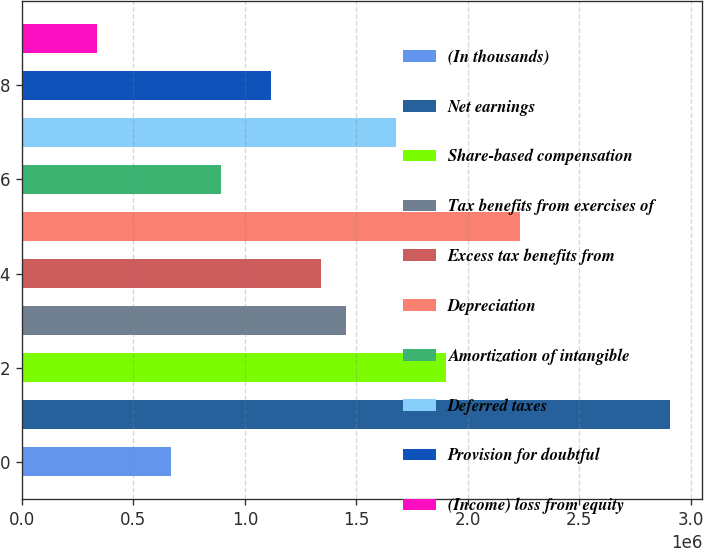<chart> <loc_0><loc_0><loc_500><loc_500><bar_chart><fcel>(In thousands)<fcel>Net earnings<fcel>Share-based compensation<fcel>Tax benefits from exercises of<fcel>Excess tax benefits from<fcel>Depreciation<fcel>Amortization of intangible<fcel>Deferred taxes<fcel>Provision for doubtful<fcel>(Income) loss from equity<nl><fcel>670869<fcel>2.90583e+06<fcel>1.9001e+06<fcel>1.4531e+06<fcel>1.34136e+06<fcel>2.23534e+06<fcel>894365<fcel>1.6766e+06<fcel>1.11786e+06<fcel>335626<nl></chart> 